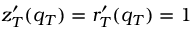<formula> <loc_0><loc_0><loc_500><loc_500>z _ { T } ^ { \prime } ( q _ { T } ) = r _ { T } ^ { \prime } ( q _ { T } ) = 1</formula> 